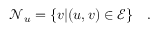Convert formula to latex. <formula><loc_0><loc_0><loc_500><loc_500>\mathcal { N } _ { u } = \{ v | ( u , v ) \in \mathcal { E } \} \quad .</formula> 